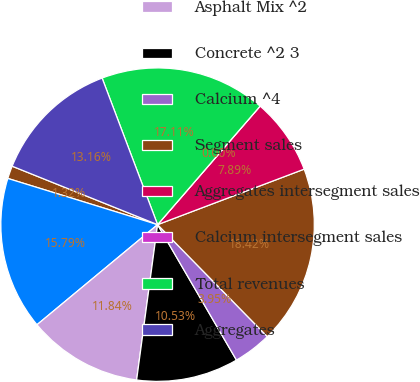Convert chart to OTSL. <chart><loc_0><loc_0><loc_500><loc_500><pie_chart><fcel>in thousands<fcel>Aggregates ^1<fcel>Asphalt Mix ^2<fcel>Concrete ^2 3<fcel>Calcium ^4<fcel>Segment sales<fcel>Aggregates intersegment sales<fcel>Calcium intersegment sales<fcel>Total revenues<fcel>Aggregates<nl><fcel>1.32%<fcel>15.79%<fcel>11.84%<fcel>10.53%<fcel>3.95%<fcel>18.42%<fcel>7.89%<fcel>0.0%<fcel>17.11%<fcel>13.16%<nl></chart> 